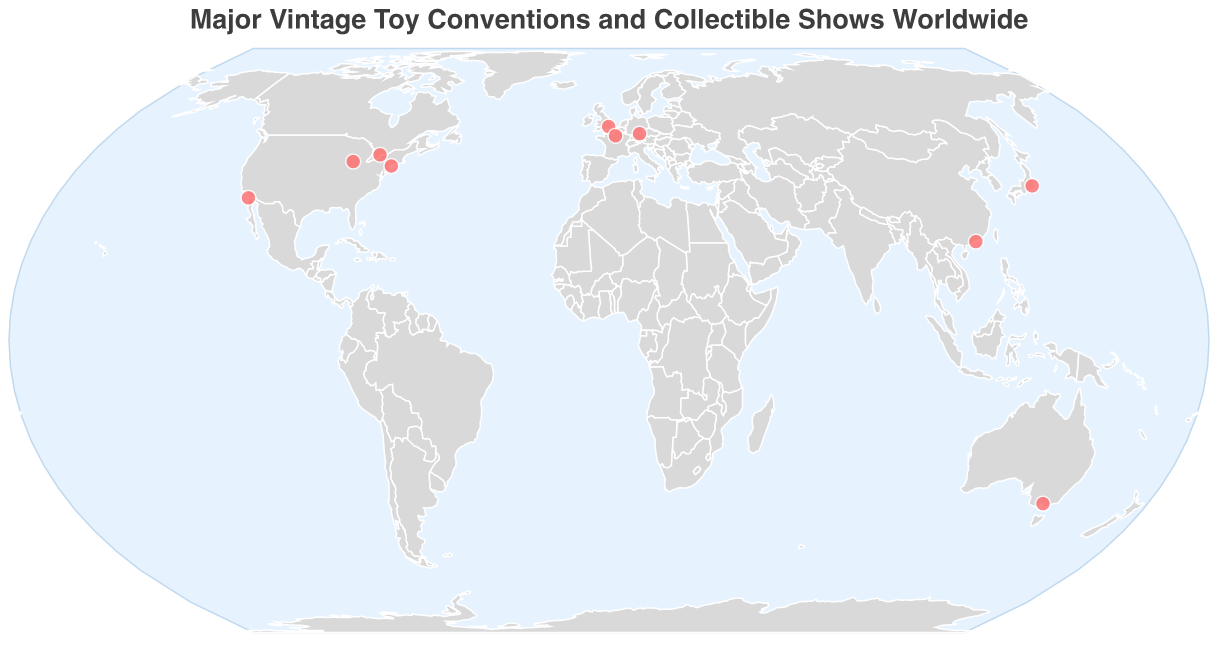What's the title of the figure? The title is typically found at the top of the figure and is used to describe the general content. In this case, the title is "Major Vintage Toy Conventions and Collectible Shows Worldwide," as explicitly stated.
Answer: Major Vintage Toy Conventions and Collectible Shows Worldwide How many major vintage toy conventions are represented in the figure? By counting the number of data points, each represented by a circle on the map, we can determine the total number of conventions. By referring to the provided data, there are 10 different locations listed.
Answer: 10 Which city hosts the "Oz Comic-Con Melbourne"? By looking at the tooltip information when hovering over the points or directly referring to the data, we see that the "Oz Comic-Con Melbourne" is hosted in Melbourne, Australia.
Answer: Melbourne Are there more conventions in North America or Europe? We count the number of conventions in each continent. In North America, there are four conventions (New York City, San Diego, Chicago, and Toronto). In Europe, there are three conventions (London, Nuremberg, and Paris). Therefore, North America has more conventions.
Answer: North America Which is the southernmost event location on the map? The southernmost location is the one with the lowest latitude value. Melbourne, Australia, with a latitude of -37.8136, is the southernmost event location among the listed conventions.
Answer: Melbourne What are the longitude and latitude of New York City? By examining the data directly, we find that New York City is located at a latitude of 40.7128 and a longitude of -74.0060.
Answer: 40.7128, -74.0060 Compare the longitude of Tokyo and Hong Kong. Which one is located further east? By comparing the longitude values of Tokyo (139.6503) and Hong Kong (114.1694), we see that Tokyo is further east since it has a higher longitude value.
Answer: Tokyo Which city in the figure is closest to the prime meridian (longitude of 0)? London, with a longitude of -0.1278, is the closest to the prime meridian compared to the other event locations. This is determined by looking at the longitude values and identifying the one closest to zero.
Answer: London How many events are hosted in cities with a name beginning with 'N'? By examining the list of cities, we find two cities that start with 'N': New York City and Nuremberg.
Answer: 2 Which event is hosted in a city located closest to the equator? By checking the latitudes and identifying the city with the smallest absolute value, we find that Hong Kong (latitude 22.3193) is the closest to the equator among the provided locations.
Answer: Hong Kong 